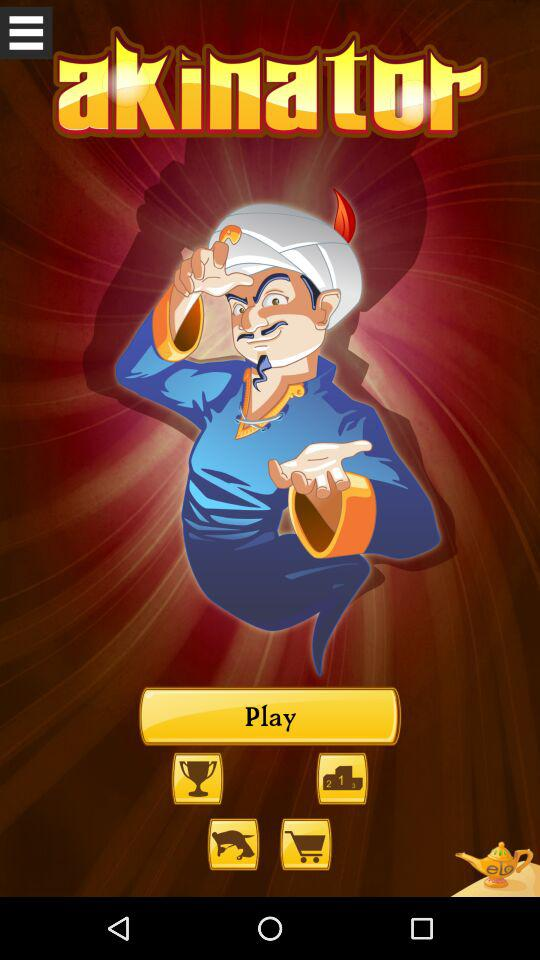What is the application name? The application name is "akinator". 